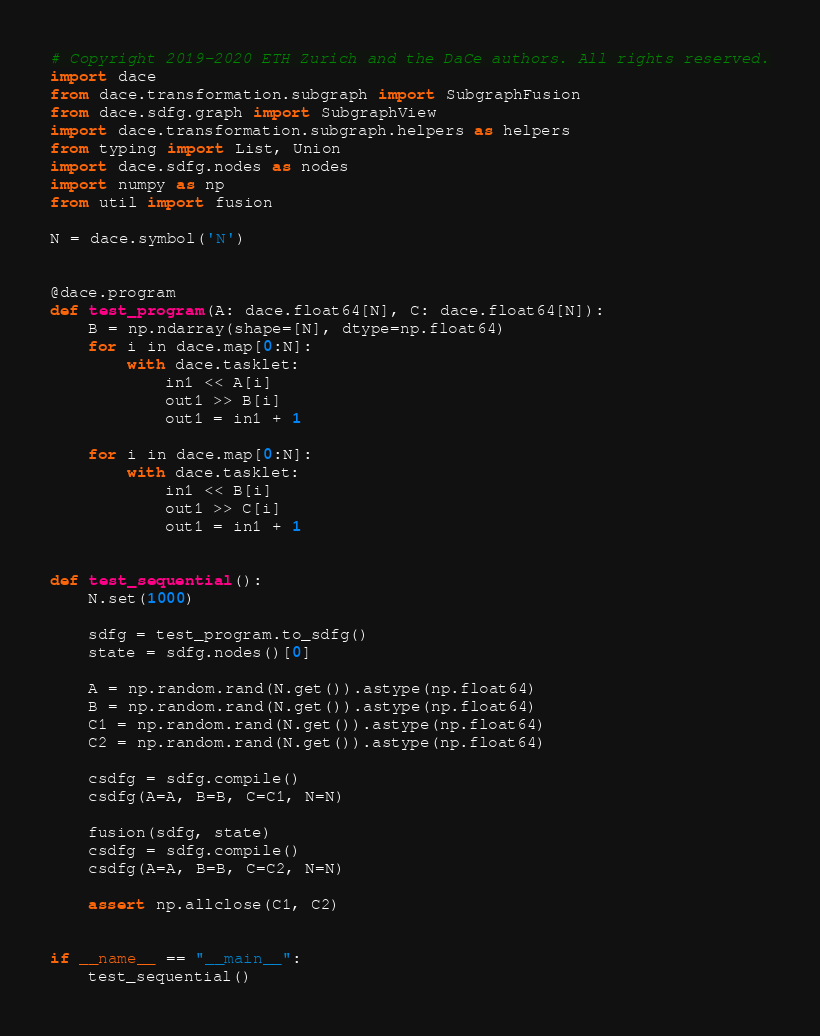<code> <loc_0><loc_0><loc_500><loc_500><_Python_># Copyright 2019-2020 ETH Zurich and the DaCe authors. All rights reserved.
import dace
from dace.transformation.subgraph import SubgraphFusion
from dace.sdfg.graph import SubgraphView
import dace.transformation.subgraph.helpers as helpers
from typing import List, Union
import dace.sdfg.nodes as nodes
import numpy as np
from util import fusion

N = dace.symbol('N')


@dace.program
def test_program(A: dace.float64[N], C: dace.float64[N]):
    B = np.ndarray(shape=[N], dtype=np.float64)
    for i in dace.map[0:N]:
        with dace.tasklet:
            in1 << A[i]
            out1 >> B[i]
            out1 = in1 + 1

    for i in dace.map[0:N]:
        with dace.tasklet:
            in1 << B[i]
            out1 >> C[i]
            out1 = in1 + 1


def test_sequential():
    N.set(1000)

    sdfg = test_program.to_sdfg()
    state = sdfg.nodes()[0]

    A = np.random.rand(N.get()).astype(np.float64)
    B = np.random.rand(N.get()).astype(np.float64)
    C1 = np.random.rand(N.get()).astype(np.float64)
    C2 = np.random.rand(N.get()).astype(np.float64)

    csdfg = sdfg.compile()
    csdfg(A=A, B=B, C=C1, N=N)

    fusion(sdfg, state)
    csdfg = sdfg.compile()
    csdfg(A=A, B=B, C=C2, N=N)

    assert np.allclose(C1, C2)


if __name__ == "__main__":
    test_sequential()
</code> 